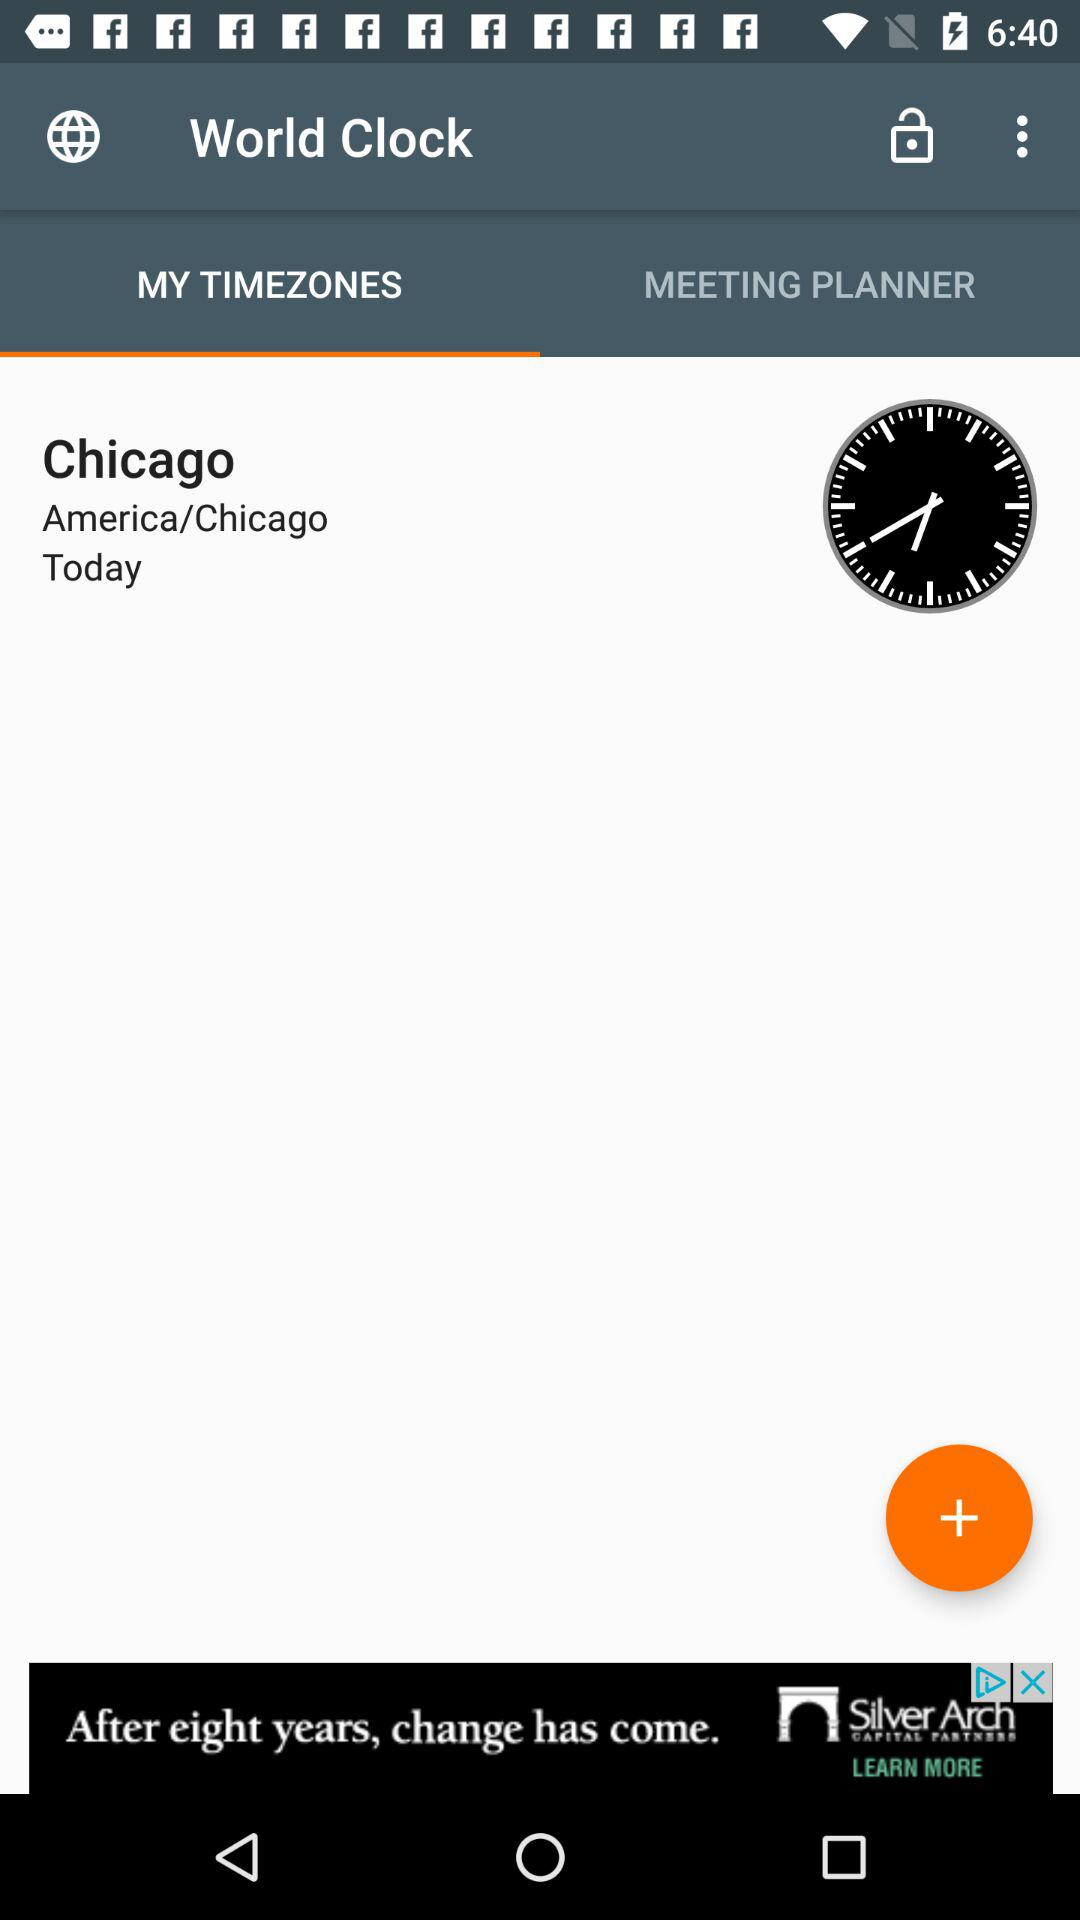Which tab has been selected? The selected tab is "MY TIMEZONES". 